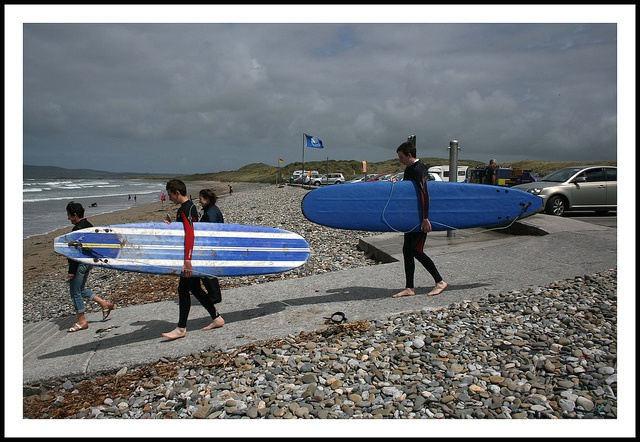Describe the objects in this image and their specific colors. I can see surfboard in black, white, blue, gray, and darkgray tones, surfboard in black, navy, blue, and darkblue tones, people in black, darkgray, gray, and maroon tones, car in black, gray, darkgray, and white tones, and people in black, brown, and maroon tones in this image. 